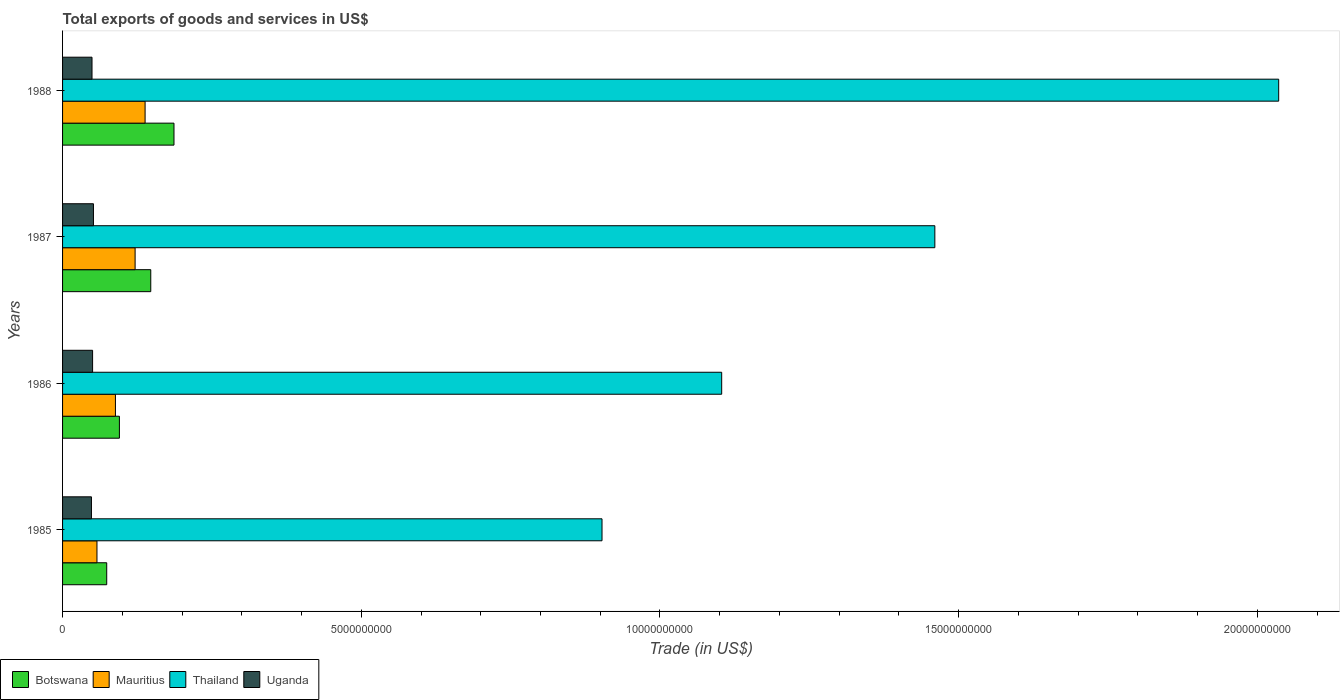Are the number of bars on each tick of the Y-axis equal?
Provide a succinct answer. Yes. How many bars are there on the 3rd tick from the bottom?
Provide a succinct answer. 4. In how many cases, is the number of bars for a given year not equal to the number of legend labels?
Provide a short and direct response. 0. What is the total exports of goods and services in Mauritius in 1987?
Offer a very short reply. 1.21e+09. Across all years, what is the maximum total exports of goods and services in Thailand?
Make the answer very short. 2.04e+1. Across all years, what is the minimum total exports of goods and services in Mauritius?
Ensure brevity in your answer.  5.76e+08. In which year was the total exports of goods and services in Mauritius maximum?
Ensure brevity in your answer.  1988. What is the total total exports of goods and services in Mauritius in the graph?
Your response must be concise. 4.06e+09. What is the difference between the total exports of goods and services in Mauritius in 1985 and that in 1987?
Make the answer very short. -6.38e+08. What is the difference between the total exports of goods and services in Botswana in 1987 and the total exports of goods and services in Mauritius in 1988?
Your answer should be compact. 9.49e+07. What is the average total exports of goods and services in Thailand per year?
Offer a terse response. 1.38e+1. In the year 1987, what is the difference between the total exports of goods and services in Thailand and total exports of goods and services in Uganda?
Your answer should be very brief. 1.41e+1. In how many years, is the total exports of goods and services in Thailand greater than 3000000000 US$?
Give a very brief answer. 4. What is the ratio of the total exports of goods and services in Uganda in 1985 to that in 1986?
Your answer should be very brief. 0.96. Is the total exports of goods and services in Uganda in 1985 less than that in 1986?
Your response must be concise. Yes. What is the difference between the highest and the second highest total exports of goods and services in Mauritius?
Keep it short and to the point. 1.67e+08. What is the difference between the highest and the lowest total exports of goods and services in Thailand?
Provide a short and direct response. 1.13e+1. Is the sum of the total exports of goods and services in Botswana in 1987 and 1988 greater than the maximum total exports of goods and services in Thailand across all years?
Provide a short and direct response. No. Is it the case that in every year, the sum of the total exports of goods and services in Mauritius and total exports of goods and services in Thailand is greater than the sum of total exports of goods and services in Uganda and total exports of goods and services in Botswana?
Offer a very short reply. Yes. What does the 3rd bar from the top in 1985 represents?
Make the answer very short. Mauritius. What does the 2nd bar from the bottom in 1988 represents?
Provide a short and direct response. Mauritius. Is it the case that in every year, the sum of the total exports of goods and services in Uganda and total exports of goods and services in Thailand is greater than the total exports of goods and services in Mauritius?
Offer a very short reply. Yes. How many bars are there?
Your answer should be very brief. 16. Are all the bars in the graph horizontal?
Keep it short and to the point. Yes. Where does the legend appear in the graph?
Your answer should be very brief. Bottom left. What is the title of the graph?
Give a very brief answer. Total exports of goods and services in US$. Does "Macao" appear as one of the legend labels in the graph?
Your answer should be very brief. No. What is the label or title of the X-axis?
Offer a terse response. Trade (in US$). What is the Trade (in US$) in Botswana in 1985?
Offer a terse response. 7.39e+08. What is the Trade (in US$) in Mauritius in 1985?
Keep it short and to the point. 5.76e+08. What is the Trade (in US$) of Thailand in 1985?
Provide a short and direct response. 9.03e+09. What is the Trade (in US$) of Uganda in 1985?
Your answer should be very brief. 4.84e+08. What is the Trade (in US$) of Botswana in 1986?
Your response must be concise. 9.52e+08. What is the Trade (in US$) in Mauritius in 1986?
Ensure brevity in your answer.  8.85e+08. What is the Trade (in US$) of Thailand in 1986?
Keep it short and to the point. 1.10e+1. What is the Trade (in US$) of Uganda in 1986?
Provide a short and direct response. 5.03e+08. What is the Trade (in US$) in Botswana in 1987?
Ensure brevity in your answer.  1.48e+09. What is the Trade (in US$) of Mauritius in 1987?
Make the answer very short. 1.21e+09. What is the Trade (in US$) of Thailand in 1987?
Provide a short and direct response. 1.46e+1. What is the Trade (in US$) of Uganda in 1987?
Ensure brevity in your answer.  5.17e+08. What is the Trade (in US$) in Botswana in 1988?
Give a very brief answer. 1.86e+09. What is the Trade (in US$) in Mauritius in 1988?
Keep it short and to the point. 1.38e+09. What is the Trade (in US$) in Thailand in 1988?
Your response must be concise. 2.04e+1. What is the Trade (in US$) of Uganda in 1988?
Offer a terse response. 4.93e+08. Across all years, what is the maximum Trade (in US$) of Botswana?
Your response must be concise. 1.86e+09. Across all years, what is the maximum Trade (in US$) of Mauritius?
Provide a short and direct response. 1.38e+09. Across all years, what is the maximum Trade (in US$) of Thailand?
Your answer should be very brief. 2.04e+1. Across all years, what is the maximum Trade (in US$) in Uganda?
Keep it short and to the point. 5.17e+08. Across all years, what is the minimum Trade (in US$) of Botswana?
Provide a short and direct response. 7.39e+08. Across all years, what is the minimum Trade (in US$) in Mauritius?
Provide a short and direct response. 5.76e+08. Across all years, what is the minimum Trade (in US$) in Thailand?
Make the answer very short. 9.03e+09. Across all years, what is the minimum Trade (in US$) of Uganda?
Offer a terse response. 4.84e+08. What is the total Trade (in US$) in Botswana in the graph?
Offer a terse response. 5.03e+09. What is the total Trade (in US$) of Mauritius in the graph?
Offer a terse response. 4.06e+09. What is the total Trade (in US$) of Thailand in the graph?
Your answer should be very brief. 5.50e+1. What is the total Trade (in US$) of Uganda in the graph?
Make the answer very short. 2.00e+09. What is the difference between the Trade (in US$) of Botswana in 1985 and that in 1986?
Offer a terse response. -2.13e+08. What is the difference between the Trade (in US$) of Mauritius in 1985 and that in 1986?
Offer a terse response. -3.09e+08. What is the difference between the Trade (in US$) in Thailand in 1985 and that in 1986?
Ensure brevity in your answer.  -2.00e+09. What is the difference between the Trade (in US$) in Uganda in 1985 and that in 1986?
Keep it short and to the point. -1.90e+07. What is the difference between the Trade (in US$) of Botswana in 1985 and that in 1987?
Offer a terse response. -7.37e+08. What is the difference between the Trade (in US$) of Mauritius in 1985 and that in 1987?
Give a very brief answer. -6.38e+08. What is the difference between the Trade (in US$) of Thailand in 1985 and that in 1987?
Provide a short and direct response. -5.57e+09. What is the difference between the Trade (in US$) of Uganda in 1985 and that in 1987?
Provide a succinct answer. -3.35e+07. What is the difference between the Trade (in US$) of Botswana in 1985 and that in 1988?
Offer a terse response. -1.13e+09. What is the difference between the Trade (in US$) in Mauritius in 1985 and that in 1988?
Offer a terse response. -8.06e+08. What is the difference between the Trade (in US$) of Thailand in 1985 and that in 1988?
Make the answer very short. -1.13e+1. What is the difference between the Trade (in US$) in Uganda in 1985 and that in 1988?
Offer a very short reply. -9.35e+06. What is the difference between the Trade (in US$) in Botswana in 1986 and that in 1987?
Keep it short and to the point. -5.25e+08. What is the difference between the Trade (in US$) of Mauritius in 1986 and that in 1987?
Provide a succinct answer. -3.29e+08. What is the difference between the Trade (in US$) of Thailand in 1986 and that in 1987?
Provide a short and direct response. -3.57e+09. What is the difference between the Trade (in US$) of Uganda in 1986 and that in 1987?
Make the answer very short. -1.45e+07. What is the difference between the Trade (in US$) of Botswana in 1986 and that in 1988?
Provide a short and direct response. -9.13e+08. What is the difference between the Trade (in US$) of Mauritius in 1986 and that in 1988?
Keep it short and to the point. -4.96e+08. What is the difference between the Trade (in US$) in Thailand in 1986 and that in 1988?
Offer a very short reply. -9.32e+09. What is the difference between the Trade (in US$) of Uganda in 1986 and that in 1988?
Offer a terse response. 9.67e+06. What is the difference between the Trade (in US$) in Botswana in 1987 and that in 1988?
Ensure brevity in your answer.  -3.89e+08. What is the difference between the Trade (in US$) of Mauritius in 1987 and that in 1988?
Your answer should be compact. -1.67e+08. What is the difference between the Trade (in US$) of Thailand in 1987 and that in 1988?
Give a very brief answer. -5.76e+09. What is the difference between the Trade (in US$) in Uganda in 1987 and that in 1988?
Keep it short and to the point. 2.42e+07. What is the difference between the Trade (in US$) of Botswana in 1985 and the Trade (in US$) of Mauritius in 1986?
Keep it short and to the point. -1.46e+08. What is the difference between the Trade (in US$) of Botswana in 1985 and the Trade (in US$) of Thailand in 1986?
Make the answer very short. -1.03e+1. What is the difference between the Trade (in US$) of Botswana in 1985 and the Trade (in US$) of Uganda in 1986?
Provide a short and direct response. 2.36e+08. What is the difference between the Trade (in US$) of Mauritius in 1985 and the Trade (in US$) of Thailand in 1986?
Your answer should be compact. -1.05e+1. What is the difference between the Trade (in US$) in Mauritius in 1985 and the Trade (in US$) in Uganda in 1986?
Ensure brevity in your answer.  7.34e+07. What is the difference between the Trade (in US$) in Thailand in 1985 and the Trade (in US$) in Uganda in 1986?
Ensure brevity in your answer.  8.53e+09. What is the difference between the Trade (in US$) of Botswana in 1985 and the Trade (in US$) of Mauritius in 1987?
Offer a very short reply. -4.75e+08. What is the difference between the Trade (in US$) in Botswana in 1985 and the Trade (in US$) in Thailand in 1987?
Offer a terse response. -1.39e+1. What is the difference between the Trade (in US$) of Botswana in 1985 and the Trade (in US$) of Uganda in 1987?
Ensure brevity in your answer.  2.22e+08. What is the difference between the Trade (in US$) of Mauritius in 1985 and the Trade (in US$) of Thailand in 1987?
Ensure brevity in your answer.  -1.40e+1. What is the difference between the Trade (in US$) in Mauritius in 1985 and the Trade (in US$) in Uganda in 1987?
Ensure brevity in your answer.  5.90e+07. What is the difference between the Trade (in US$) of Thailand in 1985 and the Trade (in US$) of Uganda in 1987?
Your response must be concise. 8.51e+09. What is the difference between the Trade (in US$) of Botswana in 1985 and the Trade (in US$) of Mauritius in 1988?
Provide a short and direct response. -6.43e+08. What is the difference between the Trade (in US$) in Botswana in 1985 and the Trade (in US$) in Thailand in 1988?
Your answer should be very brief. -1.96e+1. What is the difference between the Trade (in US$) of Botswana in 1985 and the Trade (in US$) of Uganda in 1988?
Offer a terse response. 2.46e+08. What is the difference between the Trade (in US$) of Mauritius in 1985 and the Trade (in US$) of Thailand in 1988?
Provide a succinct answer. -1.98e+1. What is the difference between the Trade (in US$) of Mauritius in 1985 and the Trade (in US$) of Uganda in 1988?
Your response must be concise. 8.31e+07. What is the difference between the Trade (in US$) of Thailand in 1985 and the Trade (in US$) of Uganda in 1988?
Keep it short and to the point. 8.54e+09. What is the difference between the Trade (in US$) of Botswana in 1986 and the Trade (in US$) of Mauritius in 1987?
Offer a very short reply. -2.63e+08. What is the difference between the Trade (in US$) of Botswana in 1986 and the Trade (in US$) of Thailand in 1987?
Make the answer very short. -1.37e+1. What is the difference between the Trade (in US$) of Botswana in 1986 and the Trade (in US$) of Uganda in 1987?
Give a very brief answer. 4.35e+08. What is the difference between the Trade (in US$) of Mauritius in 1986 and the Trade (in US$) of Thailand in 1987?
Provide a succinct answer. -1.37e+1. What is the difference between the Trade (in US$) of Mauritius in 1986 and the Trade (in US$) of Uganda in 1987?
Provide a short and direct response. 3.68e+08. What is the difference between the Trade (in US$) in Thailand in 1986 and the Trade (in US$) in Uganda in 1987?
Provide a succinct answer. 1.05e+1. What is the difference between the Trade (in US$) in Botswana in 1986 and the Trade (in US$) in Mauritius in 1988?
Provide a short and direct response. -4.30e+08. What is the difference between the Trade (in US$) in Botswana in 1986 and the Trade (in US$) in Thailand in 1988?
Offer a terse response. -1.94e+1. What is the difference between the Trade (in US$) in Botswana in 1986 and the Trade (in US$) in Uganda in 1988?
Keep it short and to the point. 4.59e+08. What is the difference between the Trade (in US$) of Mauritius in 1986 and the Trade (in US$) of Thailand in 1988?
Make the answer very short. -1.95e+1. What is the difference between the Trade (in US$) of Mauritius in 1986 and the Trade (in US$) of Uganda in 1988?
Make the answer very short. 3.92e+08. What is the difference between the Trade (in US$) of Thailand in 1986 and the Trade (in US$) of Uganda in 1988?
Offer a very short reply. 1.05e+1. What is the difference between the Trade (in US$) of Botswana in 1987 and the Trade (in US$) of Mauritius in 1988?
Ensure brevity in your answer.  9.49e+07. What is the difference between the Trade (in US$) of Botswana in 1987 and the Trade (in US$) of Thailand in 1988?
Make the answer very short. -1.89e+1. What is the difference between the Trade (in US$) of Botswana in 1987 and the Trade (in US$) of Uganda in 1988?
Make the answer very short. 9.84e+08. What is the difference between the Trade (in US$) in Mauritius in 1987 and the Trade (in US$) in Thailand in 1988?
Your response must be concise. -1.91e+1. What is the difference between the Trade (in US$) of Mauritius in 1987 and the Trade (in US$) of Uganda in 1988?
Keep it short and to the point. 7.21e+08. What is the difference between the Trade (in US$) in Thailand in 1987 and the Trade (in US$) in Uganda in 1988?
Offer a very short reply. 1.41e+1. What is the average Trade (in US$) in Botswana per year?
Ensure brevity in your answer.  1.26e+09. What is the average Trade (in US$) in Mauritius per year?
Your response must be concise. 1.01e+09. What is the average Trade (in US$) in Thailand per year?
Ensure brevity in your answer.  1.38e+1. What is the average Trade (in US$) of Uganda per year?
Provide a succinct answer. 4.99e+08. In the year 1985, what is the difference between the Trade (in US$) of Botswana and Trade (in US$) of Mauritius?
Provide a succinct answer. 1.63e+08. In the year 1985, what is the difference between the Trade (in US$) of Botswana and Trade (in US$) of Thailand?
Keep it short and to the point. -8.29e+09. In the year 1985, what is the difference between the Trade (in US$) in Botswana and Trade (in US$) in Uganda?
Give a very brief answer. 2.55e+08. In the year 1985, what is the difference between the Trade (in US$) in Mauritius and Trade (in US$) in Thailand?
Give a very brief answer. -8.45e+09. In the year 1985, what is the difference between the Trade (in US$) in Mauritius and Trade (in US$) in Uganda?
Your response must be concise. 9.25e+07. In the year 1985, what is the difference between the Trade (in US$) in Thailand and Trade (in US$) in Uganda?
Offer a terse response. 8.55e+09. In the year 1986, what is the difference between the Trade (in US$) in Botswana and Trade (in US$) in Mauritius?
Make the answer very short. 6.65e+07. In the year 1986, what is the difference between the Trade (in US$) in Botswana and Trade (in US$) in Thailand?
Provide a succinct answer. -1.01e+1. In the year 1986, what is the difference between the Trade (in US$) in Botswana and Trade (in US$) in Uganda?
Give a very brief answer. 4.49e+08. In the year 1986, what is the difference between the Trade (in US$) of Mauritius and Trade (in US$) of Thailand?
Your response must be concise. -1.01e+1. In the year 1986, what is the difference between the Trade (in US$) in Mauritius and Trade (in US$) in Uganda?
Your response must be concise. 3.83e+08. In the year 1986, what is the difference between the Trade (in US$) of Thailand and Trade (in US$) of Uganda?
Your answer should be compact. 1.05e+1. In the year 1987, what is the difference between the Trade (in US$) of Botswana and Trade (in US$) of Mauritius?
Your answer should be very brief. 2.62e+08. In the year 1987, what is the difference between the Trade (in US$) of Botswana and Trade (in US$) of Thailand?
Offer a terse response. -1.31e+1. In the year 1987, what is the difference between the Trade (in US$) in Botswana and Trade (in US$) in Uganda?
Give a very brief answer. 9.59e+08. In the year 1987, what is the difference between the Trade (in US$) in Mauritius and Trade (in US$) in Thailand?
Give a very brief answer. -1.34e+1. In the year 1987, what is the difference between the Trade (in US$) in Mauritius and Trade (in US$) in Uganda?
Give a very brief answer. 6.97e+08. In the year 1987, what is the difference between the Trade (in US$) of Thailand and Trade (in US$) of Uganda?
Provide a succinct answer. 1.41e+1. In the year 1988, what is the difference between the Trade (in US$) in Botswana and Trade (in US$) in Mauritius?
Offer a very short reply. 4.83e+08. In the year 1988, what is the difference between the Trade (in US$) in Botswana and Trade (in US$) in Thailand?
Make the answer very short. -1.85e+1. In the year 1988, what is the difference between the Trade (in US$) of Botswana and Trade (in US$) of Uganda?
Your answer should be very brief. 1.37e+09. In the year 1988, what is the difference between the Trade (in US$) in Mauritius and Trade (in US$) in Thailand?
Your answer should be compact. -1.90e+1. In the year 1988, what is the difference between the Trade (in US$) of Mauritius and Trade (in US$) of Uganda?
Provide a succinct answer. 8.89e+08. In the year 1988, what is the difference between the Trade (in US$) of Thailand and Trade (in US$) of Uganda?
Your response must be concise. 1.99e+1. What is the ratio of the Trade (in US$) of Botswana in 1985 to that in 1986?
Your response must be concise. 0.78. What is the ratio of the Trade (in US$) of Mauritius in 1985 to that in 1986?
Provide a succinct answer. 0.65. What is the ratio of the Trade (in US$) in Thailand in 1985 to that in 1986?
Offer a very short reply. 0.82. What is the ratio of the Trade (in US$) in Uganda in 1985 to that in 1986?
Ensure brevity in your answer.  0.96. What is the ratio of the Trade (in US$) of Botswana in 1985 to that in 1987?
Your answer should be very brief. 0.5. What is the ratio of the Trade (in US$) of Mauritius in 1985 to that in 1987?
Offer a very short reply. 0.47. What is the ratio of the Trade (in US$) of Thailand in 1985 to that in 1987?
Make the answer very short. 0.62. What is the ratio of the Trade (in US$) in Uganda in 1985 to that in 1987?
Provide a succinct answer. 0.94. What is the ratio of the Trade (in US$) of Botswana in 1985 to that in 1988?
Offer a very short reply. 0.4. What is the ratio of the Trade (in US$) in Mauritius in 1985 to that in 1988?
Offer a very short reply. 0.42. What is the ratio of the Trade (in US$) in Thailand in 1985 to that in 1988?
Your answer should be compact. 0.44. What is the ratio of the Trade (in US$) of Botswana in 1986 to that in 1987?
Make the answer very short. 0.64. What is the ratio of the Trade (in US$) of Mauritius in 1986 to that in 1987?
Offer a terse response. 0.73. What is the ratio of the Trade (in US$) of Thailand in 1986 to that in 1987?
Offer a terse response. 0.76. What is the ratio of the Trade (in US$) in Uganda in 1986 to that in 1987?
Provide a short and direct response. 0.97. What is the ratio of the Trade (in US$) in Botswana in 1986 to that in 1988?
Make the answer very short. 0.51. What is the ratio of the Trade (in US$) in Mauritius in 1986 to that in 1988?
Give a very brief answer. 0.64. What is the ratio of the Trade (in US$) of Thailand in 1986 to that in 1988?
Give a very brief answer. 0.54. What is the ratio of the Trade (in US$) of Uganda in 1986 to that in 1988?
Ensure brevity in your answer.  1.02. What is the ratio of the Trade (in US$) in Botswana in 1987 to that in 1988?
Your response must be concise. 0.79. What is the ratio of the Trade (in US$) in Mauritius in 1987 to that in 1988?
Provide a succinct answer. 0.88. What is the ratio of the Trade (in US$) of Thailand in 1987 to that in 1988?
Provide a succinct answer. 0.72. What is the ratio of the Trade (in US$) of Uganda in 1987 to that in 1988?
Provide a short and direct response. 1.05. What is the difference between the highest and the second highest Trade (in US$) in Botswana?
Your answer should be compact. 3.89e+08. What is the difference between the highest and the second highest Trade (in US$) in Mauritius?
Offer a terse response. 1.67e+08. What is the difference between the highest and the second highest Trade (in US$) in Thailand?
Ensure brevity in your answer.  5.76e+09. What is the difference between the highest and the second highest Trade (in US$) in Uganda?
Your answer should be compact. 1.45e+07. What is the difference between the highest and the lowest Trade (in US$) in Botswana?
Your answer should be very brief. 1.13e+09. What is the difference between the highest and the lowest Trade (in US$) in Mauritius?
Give a very brief answer. 8.06e+08. What is the difference between the highest and the lowest Trade (in US$) of Thailand?
Provide a short and direct response. 1.13e+1. What is the difference between the highest and the lowest Trade (in US$) of Uganda?
Give a very brief answer. 3.35e+07. 